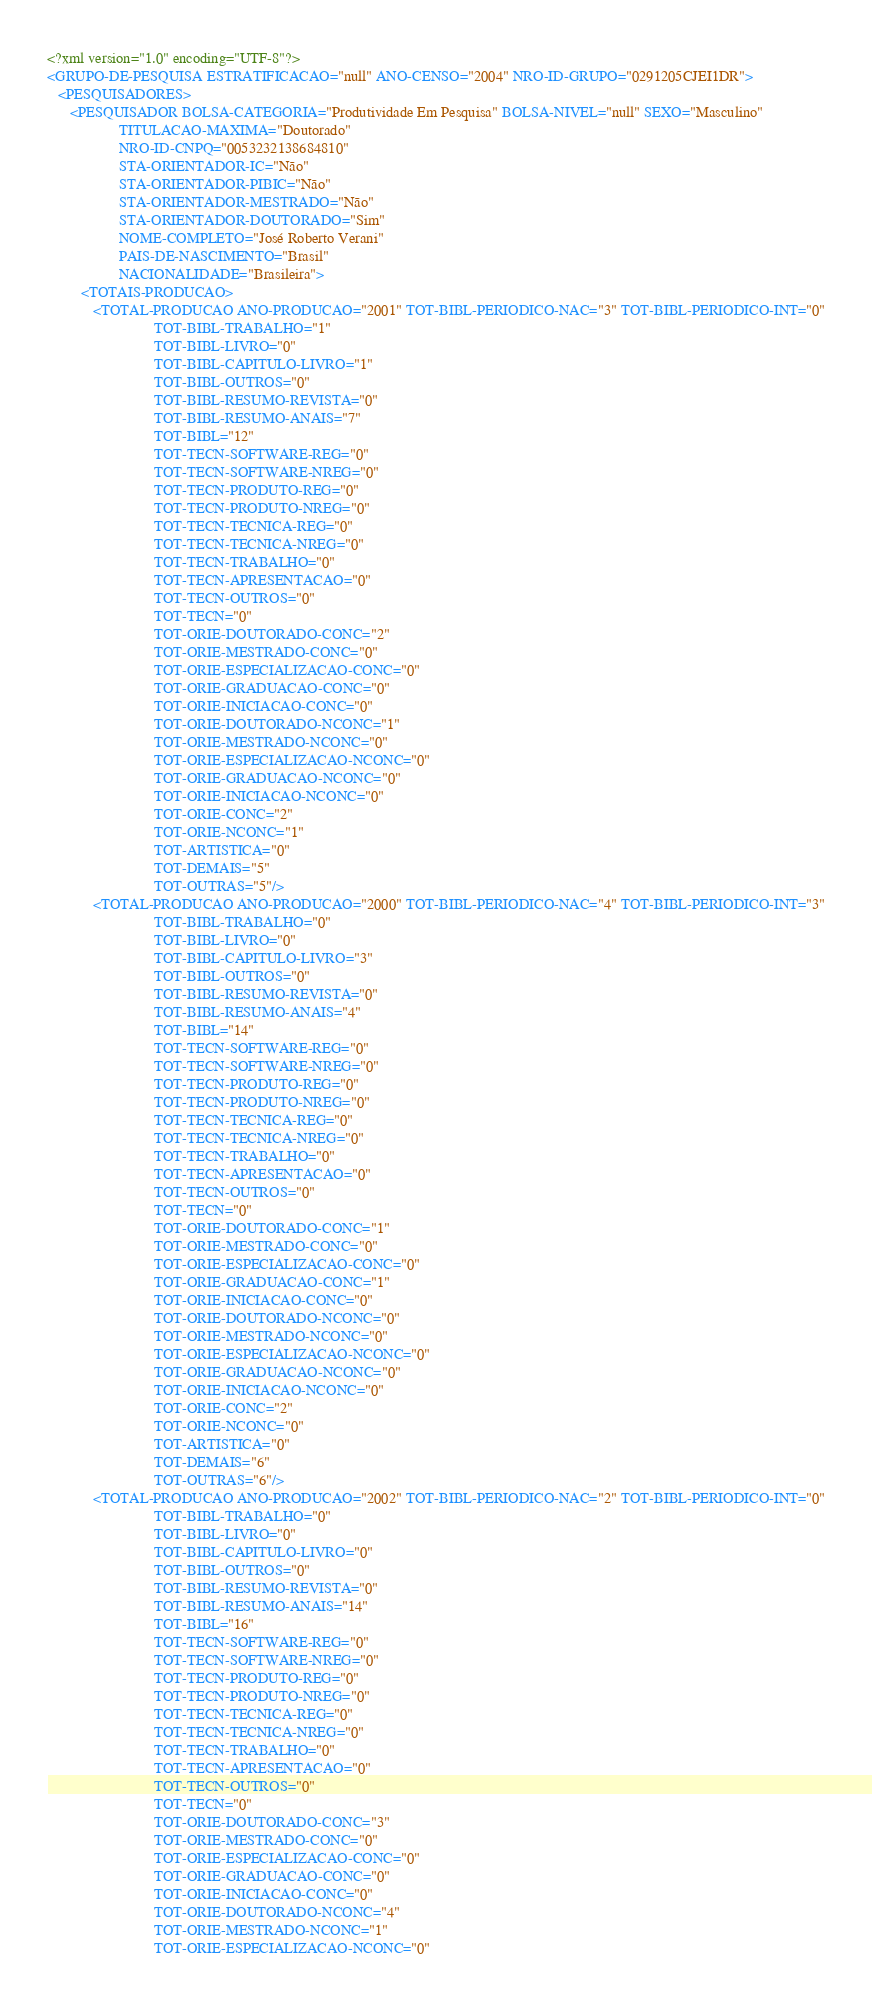<code> <loc_0><loc_0><loc_500><loc_500><_XML_><?xml version="1.0" encoding="UTF-8"?>
<GRUPO-DE-PESQUISA ESTRATIFICACAO="null" ANO-CENSO="2004" NRO-ID-GRUPO="0291205CJEI1DR">
   <PESQUISADORES>
      <PESQUISADOR BOLSA-CATEGORIA="Produtividade Em Pesquisa" BOLSA-NIVEL="null" SEXO="Masculino"
                   TITULACAO-MAXIMA="Doutorado"
                   NRO-ID-CNPQ="0053232138684810"
                   STA-ORIENTADOR-IC="Não"
                   STA-ORIENTADOR-PIBIC="Não"
                   STA-ORIENTADOR-MESTRADO="Não"
                   STA-ORIENTADOR-DOUTORADO="Sim"
                   NOME-COMPLETO="José Roberto Verani"
                   PAIS-DE-NASCIMENTO="Brasil"
                   NACIONALIDADE="Brasileira">
         <TOTAIS-PRODUCAO>
            <TOTAL-PRODUCAO ANO-PRODUCAO="2001" TOT-BIBL-PERIODICO-NAC="3" TOT-BIBL-PERIODICO-INT="0"
                            TOT-BIBL-TRABALHO="1"
                            TOT-BIBL-LIVRO="0"
                            TOT-BIBL-CAPITULO-LIVRO="1"
                            TOT-BIBL-OUTROS="0"
                            TOT-BIBL-RESUMO-REVISTA="0"
                            TOT-BIBL-RESUMO-ANAIS="7"
                            TOT-BIBL="12"
                            TOT-TECN-SOFTWARE-REG="0"
                            TOT-TECN-SOFTWARE-NREG="0"
                            TOT-TECN-PRODUTO-REG="0"
                            TOT-TECN-PRODUTO-NREG="0"
                            TOT-TECN-TECNICA-REG="0"
                            TOT-TECN-TECNICA-NREG="0"
                            TOT-TECN-TRABALHO="0"
                            TOT-TECN-APRESENTACAO="0"
                            TOT-TECN-OUTROS="0"
                            TOT-TECN="0"
                            TOT-ORIE-DOUTORADO-CONC="2"
                            TOT-ORIE-MESTRADO-CONC="0"
                            TOT-ORIE-ESPECIALIZACAO-CONC="0"
                            TOT-ORIE-GRADUACAO-CONC="0"
                            TOT-ORIE-INICIACAO-CONC="0"
                            TOT-ORIE-DOUTORADO-NCONC="1"
                            TOT-ORIE-MESTRADO-NCONC="0"
                            TOT-ORIE-ESPECIALIZACAO-NCONC="0"
                            TOT-ORIE-GRADUACAO-NCONC="0"
                            TOT-ORIE-INICIACAO-NCONC="0"
                            TOT-ORIE-CONC="2"
                            TOT-ORIE-NCONC="1"
                            TOT-ARTISTICA="0"
                            TOT-DEMAIS="5"
                            TOT-OUTRAS="5"/>
            <TOTAL-PRODUCAO ANO-PRODUCAO="2000" TOT-BIBL-PERIODICO-NAC="4" TOT-BIBL-PERIODICO-INT="3"
                            TOT-BIBL-TRABALHO="0"
                            TOT-BIBL-LIVRO="0"
                            TOT-BIBL-CAPITULO-LIVRO="3"
                            TOT-BIBL-OUTROS="0"
                            TOT-BIBL-RESUMO-REVISTA="0"
                            TOT-BIBL-RESUMO-ANAIS="4"
                            TOT-BIBL="14"
                            TOT-TECN-SOFTWARE-REG="0"
                            TOT-TECN-SOFTWARE-NREG="0"
                            TOT-TECN-PRODUTO-REG="0"
                            TOT-TECN-PRODUTO-NREG="0"
                            TOT-TECN-TECNICA-REG="0"
                            TOT-TECN-TECNICA-NREG="0"
                            TOT-TECN-TRABALHO="0"
                            TOT-TECN-APRESENTACAO="0"
                            TOT-TECN-OUTROS="0"
                            TOT-TECN="0"
                            TOT-ORIE-DOUTORADO-CONC="1"
                            TOT-ORIE-MESTRADO-CONC="0"
                            TOT-ORIE-ESPECIALIZACAO-CONC="0"
                            TOT-ORIE-GRADUACAO-CONC="1"
                            TOT-ORIE-INICIACAO-CONC="0"
                            TOT-ORIE-DOUTORADO-NCONC="0"
                            TOT-ORIE-MESTRADO-NCONC="0"
                            TOT-ORIE-ESPECIALIZACAO-NCONC="0"
                            TOT-ORIE-GRADUACAO-NCONC="0"
                            TOT-ORIE-INICIACAO-NCONC="0"
                            TOT-ORIE-CONC="2"
                            TOT-ORIE-NCONC="0"
                            TOT-ARTISTICA="0"
                            TOT-DEMAIS="6"
                            TOT-OUTRAS="6"/>
            <TOTAL-PRODUCAO ANO-PRODUCAO="2002" TOT-BIBL-PERIODICO-NAC="2" TOT-BIBL-PERIODICO-INT="0"
                            TOT-BIBL-TRABALHO="0"
                            TOT-BIBL-LIVRO="0"
                            TOT-BIBL-CAPITULO-LIVRO="0"
                            TOT-BIBL-OUTROS="0"
                            TOT-BIBL-RESUMO-REVISTA="0"
                            TOT-BIBL-RESUMO-ANAIS="14"
                            TOT-BIBL="16"
                            TOT-TECN-SOFTWARE-REG="0"
                            TOT-TECN-SOFTWARE-NREG="0"
                            TOT-TECN-PRODUTO-REG="0"
                            TOT-TECN-PRODUTO-NREG="0"
                            TOT-TECN-TECNICA-REG="0"
                            TOT-TECN-TECNICA-NREG="0"
                            TOT-TECN-TRABALHO="0"
                            TOT-TECN-APRESENTACAO="0"
                            TOT-TECN-OUTROS="0"
                            TOT-TECN="0"
                            TOT-ORIE-DOUTORADO-CONC="3"
                            TOT-ORIE-MESTRADO-CONC="0"
                            TOT-ORIE-ESPECIALIZACAO-CONC="0"
                            TOT-ORIE-GRADUACAO-CONC="0"
                            TOT-ORIE-INICIACAO-CONC="0"
                            TOT-ORIE-DOUTORADO-NCONC="4"
                            TOT-ORIE-MESTRADO-NCONC="1"
                            TOT-ORIE-ESPECIALIZACAO-NCONC="0"</code> 